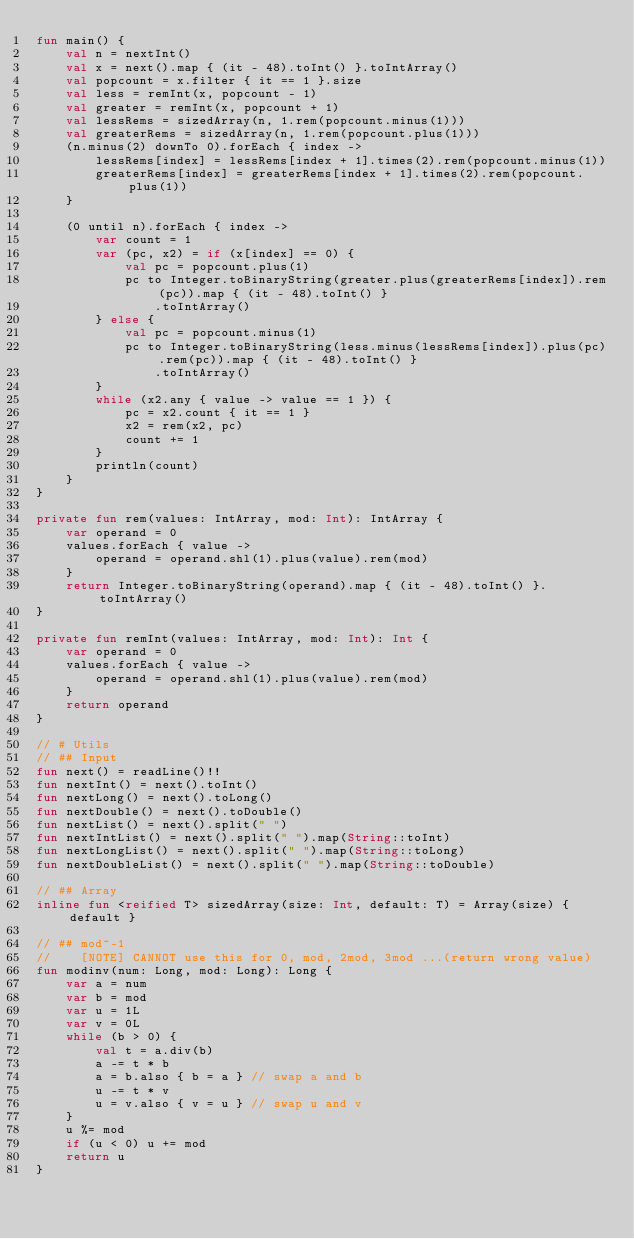<code> <loc_0><loc_0><loc_500><loc_500><_Kotlin_>fun main() {
    val n = nextInt()
    val x = next().map { (it - 48).toInt() }.toIntArray()
    val popcount = x.filter { it == 1 }.size
    val less = remInt(x, popcount - 1)
    val greater = remInt(x, popcount + 1)
    val lessRems = sizedArray(n, 1.rem(popcount.minus(1)))
    val greaterRems = sizedArray(n, 1.rem(popcount.plus(1)))
    (n.minus(2) downTo 0).forEach { index ->
        lessRems[index] = lessRems[index + 1].times(2).rem(popcount.minus(1))
        greaterRems[index] = greaterRems[index + 1].times(2).rem(popcount.plus(1))
    }

    (0 until n).forEach { index ->
        var count = 1
        var (pc, x2) = if (x[index] == 0) {
            val pc = popcount.plus(1)
            pc to Integer.toBinaryString(greater.plus(greaterRems[index]).rem(pc)).map { (it - 48).toInt() }
                .toIntArray()
        } else {
            val pc = popcount.minus(1)
            pc to Integer.toBinaryString(less.minus(lessRems[index]).plus(pc).rem(pc)).map { (it - 48).toInt() }
                .toIntArray()
        }
        while (x2.any { value -> value == 1 }) {
            pc = x2.count { it == 1 }
            x2 = rem(x2, pc)
            count += 1
        }
        println(count)
    }
}

private fun rem(values: IntArray, mod: Int): IntArray {
    var operand = 0
    values.forEach { value ->
        operand = operand.shl(1).plus(value).rem(mod)
    }
    return Integer.toBinaryString(operand).map { (it - 48).toInt() }.toIntArray()
}

private fun remInt(values: IntArray, mod: Int): Int {
    var operand = 0
    values.forEach { value ->
        operand = operand.shl(1).plus(value).rem(mod)
    }
    return operand
}

// # Utils
// ## Input
fun next() = readLine()!!
fun nextInt() = next().toInt()
fun nextLong() = next().toLong()
fun nextDouble() = next().toDouble()
fun nextList() = next().split(" ")
fun nextIntList() = next().split(" ").map(String::toInt)
fun nextLongList() = next().split(" ").map(String::toLong)
fun nextDoubleList() = next().split(" ").map(String::toDouble)

// ## Array
inline fun <reified T> sizedArray(size: Int, default: T) = Array(size) { default }

// ## mod^-1
//    [NOTE] CANNOT use this for 0, mod, 2mod, 3mod ...(return wrong value)
fun modinv(num: Long, mod: Long): Long {
    var a = num
    var b = mod
    var u = 1L
    var v = 0L
    while (b > 0) {
        val t = a.div(b)
        a -= t * b
        a = b.also { b = a } // swap a and b
        u -= t * v
        u = v.also { v = u } // swap u and v
    }
    u %= mod
    if (u < 0) u += mod
    return u
}</code> 